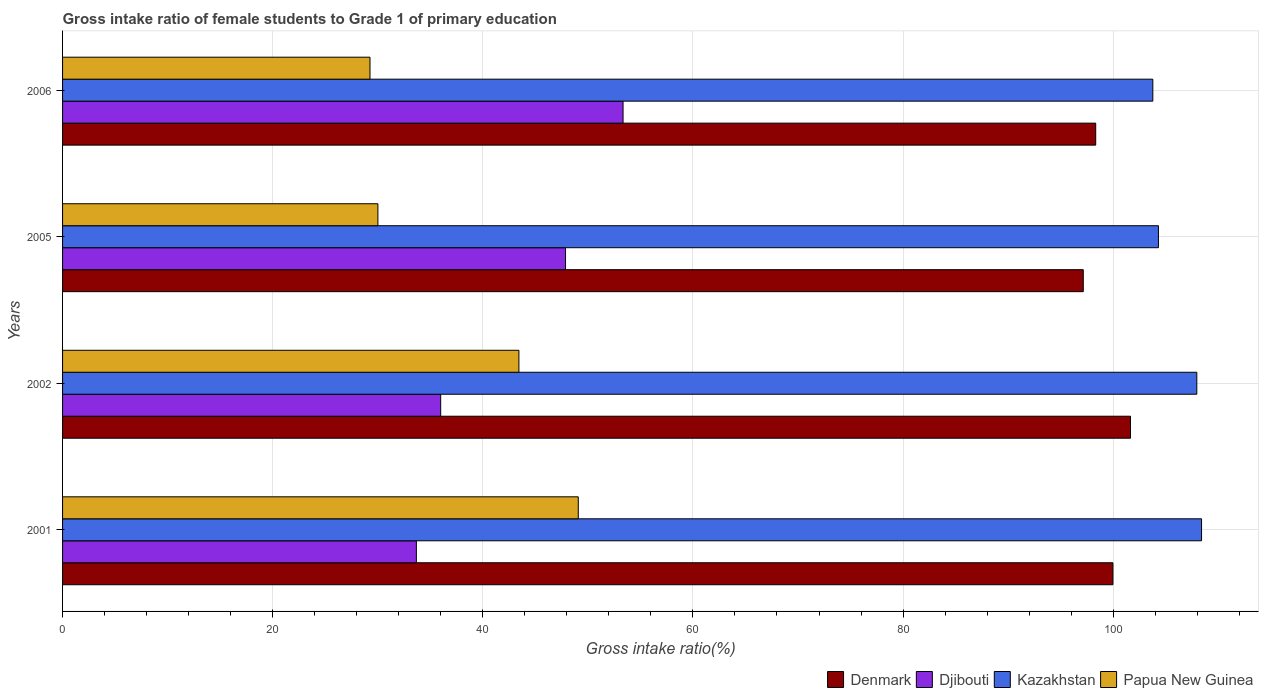How many groups of bars are there?
Make the answer very short. 4. How many bars are there on the 2nd tick from the bottom?
Offer a terse response. 4. In how many cases, is the number of bars for a given year not equal to the number of legend labels?
Keep it short and to the point. 0. What is the gross intake ratio in Djibouti in 2002?
Give a very brief answer. 35.99. Across all years, what is the maximum gross intake ratio in Papua New Guinea?
Make the answer very short. 49.09. Across all years, what is the minimum gross intake ratio in Kazakhstan?
Your answer should be compact. 103.77. What is the total gross intake ratio in Papua New Guinea in the graph?
Provide a short and direct response. 151.8. What is the difference between the gross intake ratio in Djibouti in 2001 and that in 2002?
Provide a succinct answer. -2.31. What is the difference between the gross intake ratio in Djibouti in 2006 and the gross intake ratio in Kazakhstan in 2005?
Make the answer very short. -50.96. What is the average gross intake ratio in Djibouti per year?
Provide a succinct answer. 42.72. In the year 2005, what is the difference between the gross intake ratio in Denmark and gross intake ratio in Papua New Guinea?
Make the answer very short. 67.14. In how many years, is the gross intake ratio in Denmark greater than 28 %?
Ensure brevity in your answer.  4. What is the ratio of the gross intake ratio in Papua New Guinea in 2001 to that in 2005?
Your answer should be compact. 1.64. Is the difference between the gross intake ratio in Denmark in 2001 and 2006 greater than the difference between the gross intake ratio in Papua New Guinea in 2001 and 2006?
Your answer should be very brief. No. What is the difference between the highest and the second highest gross intake ratio in Kazakhstan?
Keep it short and to the point. 0.45. What is the difference between the highest and the lowest gross intake ratio in Papua New Guinea?
Give a very brief answer. 19.83. In how many years, is the gross intake ratio in Papua New Guinea greater than the average gross intake ratio in Papua New Guinea taken over all years?
Your answer should be compact. 2. What does the 1st bar from the top in 2001 represents?
Ensure brevity in your answer.  Papua New Guinea. What does the 4th bar from the bottom in 2001 represents?
Make the answer very short. Papua New Guinea. How many bars are there?
Keep it short and to the point. 16. Are all the bars in the graph horizontal?
Your answer should be very brief. Yes. What is the difference between two consecutive major ticks on the X-axis?
Keep it short and to the point. 20. Does the graph contain grids?
Provide a short and direct response. Yes. How many legend labels are there?
Your response must be concise. 4. What is the title of the graph?
Make the answer very short. Gross intake ratio of female students to Grade 1 of primary education. Does "New Zealand" appear as one of the legend labels in the graph?
Provide a succinct answer. No. What is the label or title of the X-axis?
Provide a short and direct response. Gross intake ratio(%). What is the label or title of the Y-axis?
Your answer should be very brief. Years. What is the Gross intake ratio(%) in Denmark in 2001?
Your answer should be very brief. 99.98. What is the Gross intake ratio(%) of Djibouti in 2001?
Keep it short and to the point. 33.68. What is the Gross intake ratio(%) of Kazakhstan in 2001?
Provide a short and direct response. 108.41. What is the Gross intake ratio(%) of Papua New Guinea in 2001?
Make the answer very short. 49.09. What is the Gross intake ratio(%) in Denmark in 2002?
Keep it short and to the point. 101.65. What is the Gross intake ratio(%) of Djibouti in 2002?
Offer a very short reply. 35.99. What is the Gross intake ratio(%) of Kazakhstan in 2002?
Offer a terse response. 107.96. What is the Gross intake ratio(%) of Papua New Guinea in 2002?
Ensure brevity in your answer.  43.44. What is the Gross intake ratio(%) in Denmark in 2005?
Ensure brevity in your answer.  97.15. What is the Gross intake ratio(%) of Djibouti in 2005?
Offer a very short reply. 47.87. What is the Gross intake ratio(%) in Kazakhstan in 2005?
Offer a terse response. 104.31. What is the Gross intake ratio(%) in Papua New Guinea in 2005?
Make the answer very short. 30.01. What is the Gross intake ratio(%) of Denmark in 2006?
Your answer should be compact. 98.34. What is the Gross intake ratio(%) in Djibouti in 2006?
Ensure brevity in your answer.  53.35. What is the Gross intake ratio(%) in Kazakhstan in 2006?
Provide a short and direct response. 103.77. What is the Gross intake ratio(%) in Papua New Guinea in 2006?
Your answer should be compact. 29.26. Across all years, what is the maximum Gross intake ratio(%) of Denmark?
Give a very brief answer. 101.65. Across all years, what is the maximum Gross intake ratio(%) in Djibouti?
Make the answer very short. 53.35. Across all years, what is the maximum Gross intake ratio(%) of Kazakhstan?
Your answer should be very brief. 108.41. Across all years, what is the maximum Gross intake ratio(%) of Papua New Guinea?
Provide a short and direct response. 49.09. Across all years, what is the minimum Gross intake ratio(%) in Denmark?
Your answer should be very brief. 97.15. Across all years, what is the minimum Gross intake ratio(%) in Djibouti?
Give a very brief answer. 33.68. Across all years, what is the minimum Gross intake ratio(%) in Kazakhstan?
Your response must be concise. 103.77. Across all years, what is the minimum Gross intake ratio(%) in Papua New Guinea?
Provide a succinct answer. 29.26. What is the total Gross intake ratio(%) in Denmark in the graph?
Your answer should be compact. 397.11. What is the total Gross intake ratio(%) in Djibouti in the graph?
Your answer should be very brief. 170.89. What is the total Gross intake ratio(%) in Kazakhstan in the graph?
Your answer should be very brief. 424.45. What is the total Gross intake ratio(%) of Papua New Guinea in the graph?
Offer a very short reply. 151.8. What is the difference between the Gross intake ratio(%) in Denmark in 2001 and that in 2002?
Provide a succinct answer. -1.67. What is the difference between the Gross intake ratio(%) in Djibouti in 2001 and that in 2002?
Your response must be concise. -2.31. What is the difference between the Gross intake ratio(%) in Kazakhstan in 2001 and that in 2002?
Ensure brevity in your answer.  0.45. What is the difference between the Gross intake ratio(%) in Papua New Guinea in 2001 and that in 2002?
Ensure brevity in your answer.  5.65. What is the difference between the Gross intake ratio(%) in Denmark in 2001 and that in 2005?
Offer a very short reply. 2.82. What is the difference between the Gross intake ratio(%) in Djibouti in 2001 and that in 2005?
Your response must be concise. -14.2. What is the difference between the Gross intake ratio(%) in Kazakhstan in 2001 and that in 2005?
Provide a short and direct response. 4.1. What is the difference between the Gross intake ratio(%) in Papua New Guinea in 2001 and that in 2005?
Make the answer very short. 19.07. What is the difference between the Gross intake ratio(%) of Denmark in 2001 and that in 2006?
Make the answer very short. 1.64. What is the difference between the Gross intake ratio(%) of Djibouti in 2001 and that in 2006?
Give a very brief answer. -19.67. What is the difference between the Gross intake ratio(%) in Kazakhstan in 2001 and that in 2006?
Keep it short and to the point. 4.64. What is the difference between the Gross intake ratio(%) of Papua New Guinea in 2001 and that in 2006?
Keep it short and to the point. 19.83. What is the difference between the Gross intake ratio(%) in Denmark in 2002 and that in 2005?
Ensure brevity in your answer.  4.5. What is the difference between the Gross intake ratio(%) of Djibouti in 2002 and that in 2005?
Your response must be concise. -11.88. What is the difference between the Gross intake ratio(%) in Kazakhstan in 2002 and that in 2005?
Ensure brevity in your answer.  3.65. What is the difference between the Gross intake ratio(%) in Papua New Guinea in 2002 and that in 2005?
Give a very brief answer. 13.42. What is the difference between the Gross intake ratio(%) in Denmark in 2002 and that in 2006?
Give a very brief answer. 3.31. What is the difference between the Gross intake ratio(%) in Djibouti in 2002 and that in 2006?
Ensure brevity in your answer.  -17.36. What is the difference between the Gross intake ratio(%) in Kazakhstan in 2002 and that in 2006?
Your answer should be compact. 4.19. What is the difference between the Gross intake ratio(%) of Papua New Guinea in 2002 and that in 2006?
Ensure brevity in your answer.  14.17. What is the difference between the Gross intake ratio(%) of Denmark in 2005 and that in 2006?
Your answer should be very brief. -1.18. What is the difference between the Gross intake ratio(%) in Djibouti in 2005 and that in 2006?
Your response must be concise. -5.48. What is the difference between the Gross intake ratio(%) in Kazakhstan in 2005 and that in 2006?
Make the answer very short. 0.53. What is the difference between the Gross intake ratio(%) in Papua New Guinea in 2005 and that in 2006?
Provide a short and direct response. 0.75. What is the difference between the Gross intake ratio(%) of Denmark in 2001 and the Gross intake ratio(%) of Djibouti in 2002?
Your answer should be very brief. 63.99. What is the difference between the Gross intake ratio(%) of Denmark in 2001 and the Gross intake ratio(%) of Kazakhstan in 2002?
Provide a short and direct response. -7.98. What is the difference between the Gross intake ratio(%) in Denmark in 2001 and the Gross intake ratio(%) in Papua New Guinea in 2002?
Give a very brief answer. 56.54. What is the difference between the Gross intake ratio(%) in Djibouti in 2001 and the Gross intake ratio(%) in Kazakhstan in 2002?
Offer a terse response. -74.28. What is the difference between the Gross intake ratio(%) of Djibouti in 2001 and the Gross intake ratio(%) of Papua New Guinea in 2002?
Offer a very short reply. -9.76. What is the difference between the Gross intake ratio(%) of Kazakhstan in 2001 and the Gross intake ratio(%) of Papua New Guinea in 2002?
Give a very brief answer. 64.97. What is the difference between the Gross intake ratio(%) of Denmark in 2001 and the Gross intake ratio(%) of Djibouti in 2005?
Offer a very short reply. 52.1. What is the difference between the Gross intake ratio(%) in Denmark in 2001 and the Gross intake ratio(%) in Kazakhstan in 2005?
Make the answer very short. -4.33. What is the difference between the Gross intake ratio(%) of Denmark in 2001 and the Gross intake ratio(%) of Papua New Guinea in 2005?
Provide a short and direct response. 69.96. What is the difference between the Gross intake ratio(%) in Djibouti in 2001 and the Gross intake ratio(%) in Kazakhstan in 2005?
Your answer should be very brief. -70.63. What is the difference between the Gross intake ratio(%) of Djibouti in 2001 and the Gross intake ratio(%) of Papua New Guinea in 2005?
Your response must be concise. 3.66. What is the difference between the Gross intake ratio(%) in Kazakhstan in 2001 and the Gross intake ratio(%) in Papua New Guinea in 2005?
Ensure brevity in your answer.  78.4. What is the difference between the Gross intake ratio(%) in Denmark in 2001 and the Gross intake ratio(%) in Djibouti in 2006?
Your answer should be very brief. 46.63. What is the difference between the Gross intake ratio(%) in Denmark in 2001 and the Gross intake ratio(%) in Kazakhstan in 2006?
Provide a succinct answer. -3.8. What is the difference between the Gross intake ratio(%) in Denmark in 2001 and the Gross intake ratio(%) in Papua New Guinea in 2006?
Ensure brevity in your answer.  70.71. What is the difference between the Gross intake ratio(%) in Djibouti in 2001 and the Gross intake ratio(%) in Kazakhstan in 2006?
Your response must be concise. -70.1. What is the difference between the Gross intake ratio(%) in Djibouti in 2001 and the Gross intake ratio(%) in Papua New Guinea in 2006?
Give a very brief answer. 4.41. What is the difference between the Gross intake ratio(%) in Kazakhstan in 2001 and the Gross intake ratio(%) in Papua New Guinea in 2006?
Offer a very short reply. 79.15. What is the difference between the Gross intake ratio(%) in Denmark in 2002 and the Gross intake ratio(%) in Djibouti in 2005?
Offer a terse response. 53.77. What is the difference between the Gross intake ratio(%) in Denmark in 2002 and the Gross intake ratio(%) in Kazakhstan in 2005?
Offer a very short reply. -2.66. What is the difference between the Gross intake ratio(%) in Denmark in 2002 and the Gross intake ratio(%) in Papua New Guinea in 2005?
Ensure brevity in your answer.  71.63. What is the difference between the Gross intake ratio(%) of Djibouti in 2002 and the Gross intake ratio(%) of Kazakhstan in 2005?
Provide a succinct answer. -68.32. What is the difference between the Gross intake ratio(%) in Djibouti in 2002 and the Gross intake ratio(%) in Papua New Guinea in 2005?
Your response must be concise. 5.98. What is the difference between the Gross intake ratio(%) in Kazakhstan in 2002 and the Gross intake ratio(%) in Papua New Guinea in 2005?
Your answer should be very brief. 77.95. What is the difference between the Gross intake ratio(%) of Denmark in 2002 and the Gross intake ratio(%) of Djibouti in 2006?
Your answer should be very brief. 48.3. What is the difference between the Gross intake ratio(%) of Denmark in 2002 and the Gross intake ratio(%) of Kazakhstan in 2006?
Offer a very short reply. -2.13. What is the difference between the Gross intake ratio(%) of Denmark in 2002 and the Gross intake ratio(%) of Papua New Guinea in 2006?
Your answer should be very brief. 72.39. What is the difference between the Gross intake ratio(%) of Djibouti in 2002 and the Gross intake ratio(%) of Kazakhstan in 2006?
Provide a succinct answer. -67.78. What is the difference between the Gross intake ratio(%) of Djibouti in 2002 and the Gross intake ratio(%) of Papua New Guinea in 2006?
Provide a succinct answer. 6.73. What is the difference between the Gross intake ratio(%) in Kazakhstan in 2002 and the Gross intake ratio(%) in Papua New Guinea in 2006?
Offer a very short reply. 78.7. What is the difference between the Gross intake ratio(%) of Denmark in 2005 and the Gross intake ratio(%) of Djibouti in 2006?
Your answer should be very brief. 43.8. What is the difference between the Gross intake ratio(%) in Denmark in 2005 and the Gross intake ratio(%) in Kazakhstan in 2006?
Make the answer very short. -6.62. What is the difference between the Gross intake ratio(%) of Denmark in 2005 and the Gross intake ratio(%) of Papua New Guinea in 2006?
Your response must be concise. 67.89. What is the difference between the Gross intake ratio(%) in Djibouti in 2005 and the Gross intake ratio(%) in Kazakhstan in 2006?
Keep it short and to the point. -55.9. What is the difference between the Gross intake ratio(%) in Djibouti in 2005 and the Gross intake ratio(%) in Papua New Guinea in 2006?
Keep it short and to the point. 18.61. What is the difference between the Gross intake ratio(%) in Kazakhstan in 2005 and the Gross intake ratio(%) in Papua New Guinea in 2006?
Make the answer very short. 75.05. What is the average Gross intake ratio(%) in Denmark per year?
Provide a succinct answer. 99.28. What is the average Gross intake ratio(%) of Djibouti per year?
Ensure brevity in your answer.  42.72. What is the average Gross intake ratio(%) in Kazakhstan per year?
Provide a succinct answer. 106.11. What is the average Gross intake ratio(%) of Papua New Guinea per year?
Provide a succinct answer. 37.95. In the year 2001, what is the difference between the Gross intake ratio(%) of Denmark and Gross intake ratio(%) of Djibouti?
Provide a succinct answer. 66.3. In the year 2001, what is the difference between the Gross intake ratio(%) in Denmark and Gross intake ratio(%) in Kazakhstan?
Offer a very short reply. -8.43. In the year 2001, what is the difference between the Gross intake ratio(%) in Denmark and Gross intake ratio(%) in Papua New Guinea?
Ensure brevity in your answer.  50.89. In the year 2001, what is the difference between the Gross intake ratio(%) in Djibouti and Gross intake ratio(%) in Kazakhstan?
Make the answer very short. -74.73. In the year 2001, what is the difference between the Gross intake ratio(%) of Djibouti and Gross intake ratio(%) of Papua New Guinea?
Keep it short and to the point. -15.41. In the year 2001, what is the difference between the Gross intake ratio(%) of Kazakhstan and Gross intake ratio(%) of Papua New Guinea?
Offer a terse response. 59.32. In the year 2002, what is the difference between the Gross intake ratio(%) in Denmark and Gross intake ratio(%) in Djibouti?
Provide a succinct answer. 65.66. In the year 2002, what is the difference between the Gross intake ratio(%) of Denmark and Gross intake ratio(%) of Kazakhstan?
Your answer should be compact. -6.31. In the year 2002, what is the difference between the Gross intake ratio(%) of Denmark and Gross intake ratio(%) of Papua New Guinea?
Provide a short and direct response. 58.21. In the year 2002, what is the difference between the Gross intake ratio(%) of Djibouti and Gross intake ratio(%) of Kazakhstan?
Provide a short and direct response. -71.97. In the year 2002, what is the difference between the Gross intake ratio(%) of Djibouti and Gross intake ratio(%) of Papua New Guinea?
Your response must be concise. -7.45. In the year 2002, what is the difference between the Gross intake ratio(%) of Kazakhstan and Gross intake ratio(%) of Papua New Guinea?
Offer a very short reply. 64.52. In the year 2005, what is the difference between the Gross intake ratio(%) in Denmark and Gross intake ratio(%) in Djibouti?
Your answer should be very brief. 49.28. In the year 2005, what is the difference between the Gross intake ratio(%) in Denmark and Gross intake ratio(%) in Kazakhstan?
Make the answer very short. -7.15. In the year 2005, what is the difference between the Gross intake ratio(%) in Denmark and Gross intake ratio(%) in Papua New Guinea?
Make the answer very short. 67.14. In the year 2005, what is the difference between the Gross intake ratio(%) in Djibouti and Gross intake ratio(%) in Kazakhstan?
Provide a short and direct response. -56.43. In the year 2005, what is the difference between the Gross intake ratio(%) in Djibouti and Gross intake ratio(%) in Papua New Guinea?
Offer a very short reply. 17.86. In the year 2005, what is the difference between the Gross intake ratio(%) of Kazakhstan and Gross intake ratio(%) of Papua New Guinea?
Keep it short and to the point. 74.29. In the year 2006, what is the difference between the Gross intake ratio(%) of Denmark and Gross intake ratio(%) of Djibouti?
Provide a succinct answer. 44.99. In the year 2006, what is the difference between the Gross intake ratio(%) in Denmark and Gross intake ratio(%) in Kazakhstan?
Provide a succinct answer. -5.44. In the year 2006, what is the difference between the Gross intake ratio(%) in Denmark and Gross intake ratio(%) in Papua New Guinea?
Provide a short and direct response. 69.07. In the year 2006, what is the difference between the Gross intake ratio(%) in Djibouti and Gross intake ratio(%) in Kazakhstan?
Your response must be concise. -50.42. In the year 2006, what is the difference between the Gross intake ratio(%) of Djibouti and Gross intake ratio(%) of Papua New Guinea?
Your answer should be compact. 24.09. In the year 2006, what is the difference between the Gross intake ratio(%) of Kazakhstan and Gross intake ratio(%) of Papua New Guinea?
Provide a succinct answer. 74.51. What is the ratio of the Gross intake ratio(%) of Denmark in 2001 to that in 2002?
Provide a short and direct response. 0.98. What is the ratio of the Gross intake ratio(%) of Djibouti in 2001 to that in 2002?
Provide a succinct answer. 0.94. What is the ratio of the Gross intake ratio(%) of Papua New Guinea in 2001 to that in 2002?
Your answer should be compact. 1.13. What is the ratio of the Gross intake ratio(%) in Denmark in 2001 to that in 2005?
Your answer should be compact. 1.03. What is the ratio of the Gross intake ratio(%) of Djibouti in 2001 to that in 2005?
Offer a terse response. 0.7. What is the ratio of the Gross intake ratio(%) of Kazakhstan in 2001 to that in 2005?
Make the answer very short. 1.04. What is the ratio of the Gross intake ratio(%) in Papua New Guinea in 2001 to that in 2005?
Your response must be concise. 1.64. What is the ratio of the Gross intake ratio(%) of Denmark in 2001 to that in 2006?
Offer a terse response. 1.02. What is the ratio of the Gross intake ratio(%) of Djibouti in 2001 to that in 2006?
Ensure brevity in your answer.  0.63. What is the ratio of the Gross intake ratio(%) in Kazakhstan in 2001 to that in 2006?
Provide a short and direct response. 1.04. What is the ratio of the Gross intake ratio(%) of Papua New Guinea in 2001 to that in 2006?
Provide a short and direct response. 1.68. What is the ratio of the Gross intake ratio(%) of Denmark in 2002 to that in 2005?
Your answer should be compact. 1.05. What is the ratio of the Gross intake ratio(%) of Djibouti in 2002 to that in 2005?
Make the answer very short. 0.75. What is the ratio of the Gross intake ratio(%) in Kazakhstan in 2002 to that in 2005?
Ensure brevity in your answer.  1.03. What is the ratio of the Gross intake ratio(%) of Papua New Guinea in 2002 to that in 2005?
Keep it short and to the point. 1.45. What is the ratio of the Gross intake ratio(%) of Denmark in 2002 to that in 2006?
Your answer should be compact. 1.03. What is the ratio of the Gross intake ratio(%) in Djibouti in 2002 to that in 2006?
Offer a terse response. 0.67. What is the ratio of the Gross intake ratio(%) in Kazakhstan in 2002 to that in 2006?
Your answer should be compact. 1.04. What is the ratio of the Gross intake ratio(%) of Papua New Guinea in 2002 to that in 2006?
Your response must be concise. 1.48. What is the ratio of the Gross intake ratio(%) of Djibouti in 2005 to that in 2006?
Ensure brevity in your answer.  0.9. What is the ratio of the Gross intake ratio(%) in Kazakhstan in 2005 to that in 2006?
Keep it short and to the point. 1.01. What is the ratio of the Gross intake ratio(%) in Papua New Guinea in 2005 to that in 2006?
Offer a very short reply. 1.03. What is the difference between the highest and the second highest Gross intake ratio(%) of Denmark?
Ensure brevity in your answer.  1.67. What is the difference between the highest and the second highest Gross intake ratio(%) of Djibouti?
Your answer should be very brief. 5.48. What is the difference between the highest and the second highest Gross intake ratio(%) in Kazakhstan?
Provide a succinct answer. 0.45. What is the difference between the highest and the second highest Gross intake ratio(%) of Papua New Guinea?
Offer a very short reply. 5.65. What is the difference between the highest and the lowest Gross intake ratio(%) of Denmark?
Offer a very short reply. 4.5. What is the difference between the highest and the lowest Gross intake ratio(%) in Djibouti?
Offer a terse response. 19.67. What is the difference between the highest and the lowest Gross intake ratio(%) of Kazakhstan?
Your answer should be compact. 4.64. What is the difference between the highest and the lowest Gross intake ratio(%) in Papua New Guinea?
Offer a terse response. 19.83. 